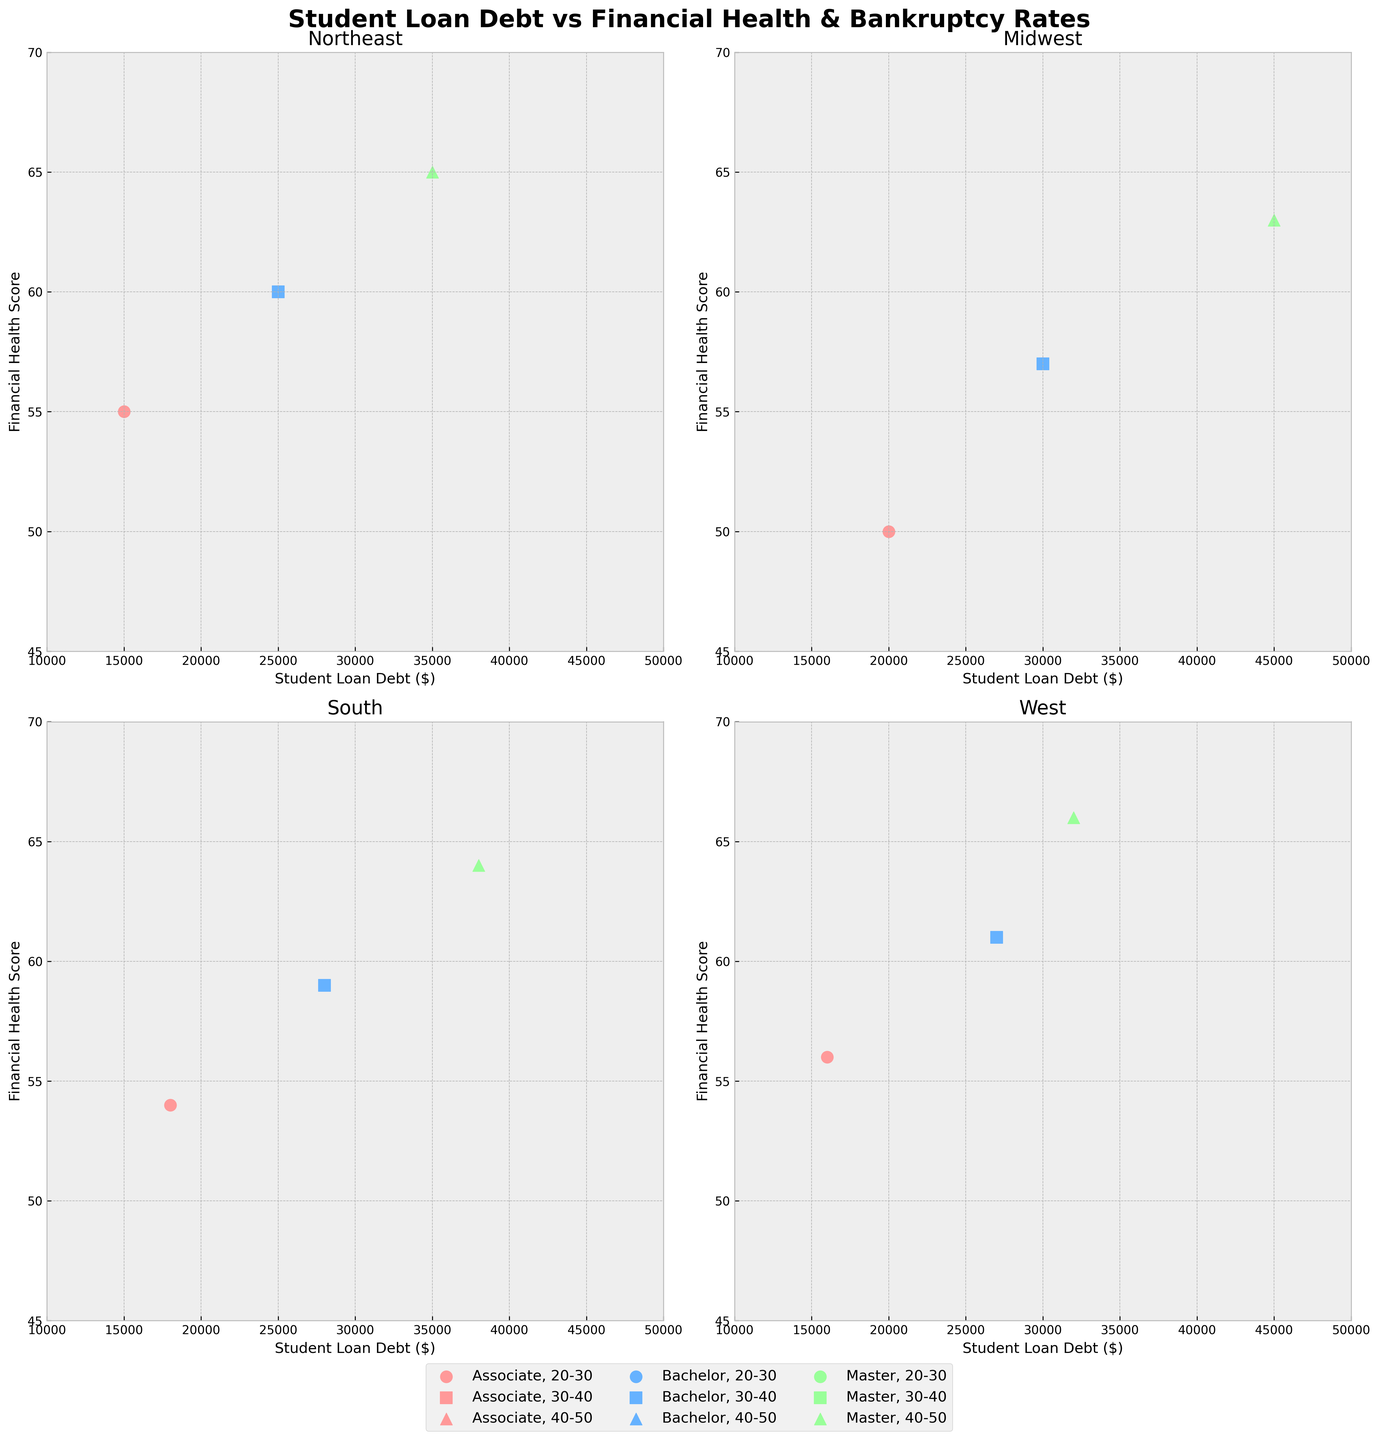Which region has the highest financial health score? By looking at the regions and their respective titles on each subplot, we find the highest value on the y-axis. The data points in the West region have the highest financial health score of 66 for 'Master' in the 40-50 age group.
Answer: West What color represents the Bachelor's educational attainment in the scatter plot? Observing the color legend and the data points in the subplots, the Bachelor's educational attainment is represented by blue color.
Answer: Blue Which age group in the Midwest region has the highest rate of bankruptcy? Referencing the markers and the bankruptcy rates within the Midwest region subplot, the group of 30-40 years old with 'Bachelor' has a bankruptcy rate of 0.05 which is the highest.
Answer: 30-40 Does the Northeast region have any age group with a financial health score below 50? Looking at the data points in the Northeast region subplot along the y-axis, we note that no age group has a financial health score below 50.
Answer: No What is the difference in financial health scores between Bachelor’s attainment in the Northeast region (30-40 age group) and the Midwest region (30-40 age group)? The Northeast region with Bachelor’s attainment in the 30-40 age group has a financial health score of 60, whereas the Midwest region in the same category has a score of 57. The difference is 60 - 57 = 3.
Answer: 3 Which region has the lowest student loan debt for the 'Associate' degree within the 20-30 age group? Checking the data points with 'Associate' degree and 20-30 age group in each subplot, we see that the West region has the lowest student loan debt at $16,000.
Answer: West In the South region, which combination of age group and educational attainment has the highest financial health score? Reviewing the data points in the South region subplot, the combination of 'Master' in the 40-50 age group has the highest financial health score of 64.
Answer: Master, 40-50 For the 'Bachelor' educational attainment level, which region displays the highest financial health score in the 30-40 age group? By examining the data points of 'Bachelor' with 30-40 age group in all regions, the West region shows the highest financial health score of 61.
Answer: West Do all regions show a positive correlation between student loan debt and financial health score? Analyzing each subplot, it can be seen that generally, there is not a consistent positive correlation where higher student loan debt leads to higher financial health scores across all regions.
Answer: No What marker symbol is used for the 20-30 age group across all regions? Observing the scatter plots, we find that circles ('o') are used as the marker symbol for the 20-30 age group in each region.
Answer: Circle 